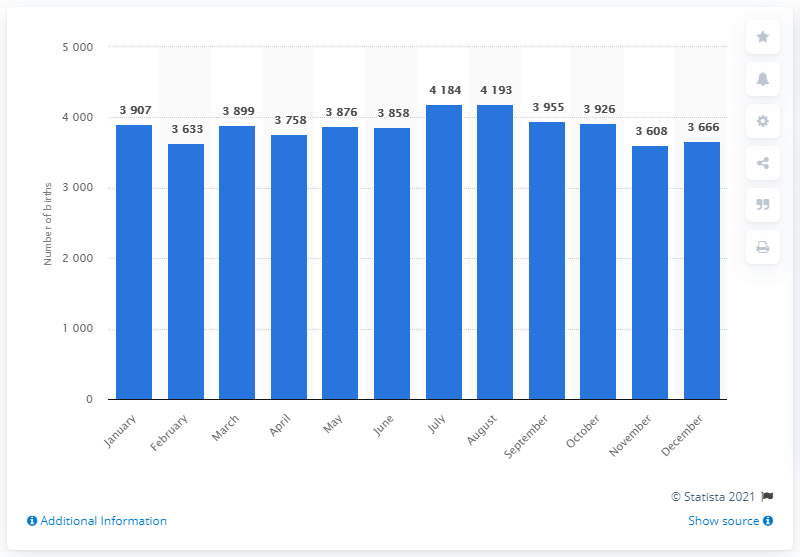Give some essential details in this illustration. In August, Finland's peak number of live births was recorded. 